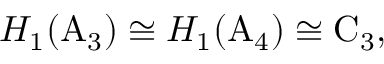Convert formula to latex. <formula><loc_0><loc_0><loc_500><loc_500>H _ { 1 } ( A _ { 3 } ) \cong H _ { 1 } ( A _ { 4 } ) \cong C _ { 3 } ,</formula> 